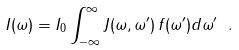<formula> <loc_0><loc_0><loc_500><loc_500>I ( \omega ) = I _ { 0 } \int _ { - \infty } ^ { \infty } J ( \omega , \omega ^ { \prime } ) \, f ( \omega ^ { \prime } ) d \omega ^ { \prime } \ .</formula> 